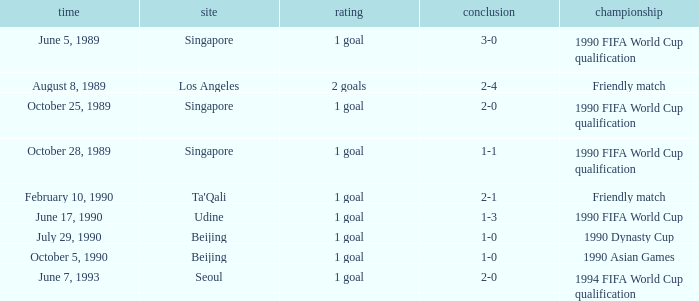What is the venue of the 1990 Asian games? Beijing. Write the full table. {'header': ['time', 'site', 'rating', 'conclusion', 'championship'], 'rows': [['June 5, 1989', 'Singapore', '1 goal', '3-0', '1990 FIFA World Cup qualification'], ['August 8, 1989', 'Los Angeles', '2 goals', '2-4', 'Friendly match'], ['October 25, 1989', 'Singapore', '1 goal', '2-0', '1990 FIFA World Cup qualification'], ['October 28, 1989', 'Singapore', '1 goal', '1-1', '1990 FIFA World Cup qualification'], ['February 10, 1990', "Ta'Qali", '1 goal', '2-1', 'Friendly match'], ['June 17, 1990', 'Udine', '1 goal', '1-3', '1990 FIFA World Cup'], ['July 29, 1990', 'Beijing', '1 goal', '1-0', '1990 Dynasty Cup'], ['October 5, 1990', 'Beijing', '1 goal', '1-0', '1990 Asian Games'], ['June 7, 1993', 'Seoul', '1 goal', '2-0', '1994 FIFA World Cup qualification']]} 